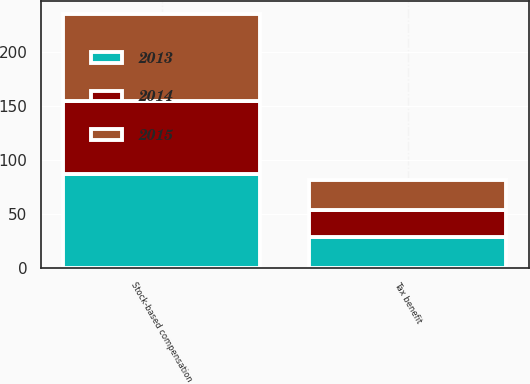<chart> <loc_0><loc_0><loc_500><loc_500><stacked_bar_chart><ecel><fcel>Stock-based compensation<fcel>Tax benefit<nl><fcel>2013<fcel>87.2<fcel>28.6<nl><fcel>2015<fcel>80.4<fcel>27.5<nl><fcel>2014<fcel>67.1<fcel>24.7<nl></chart> 